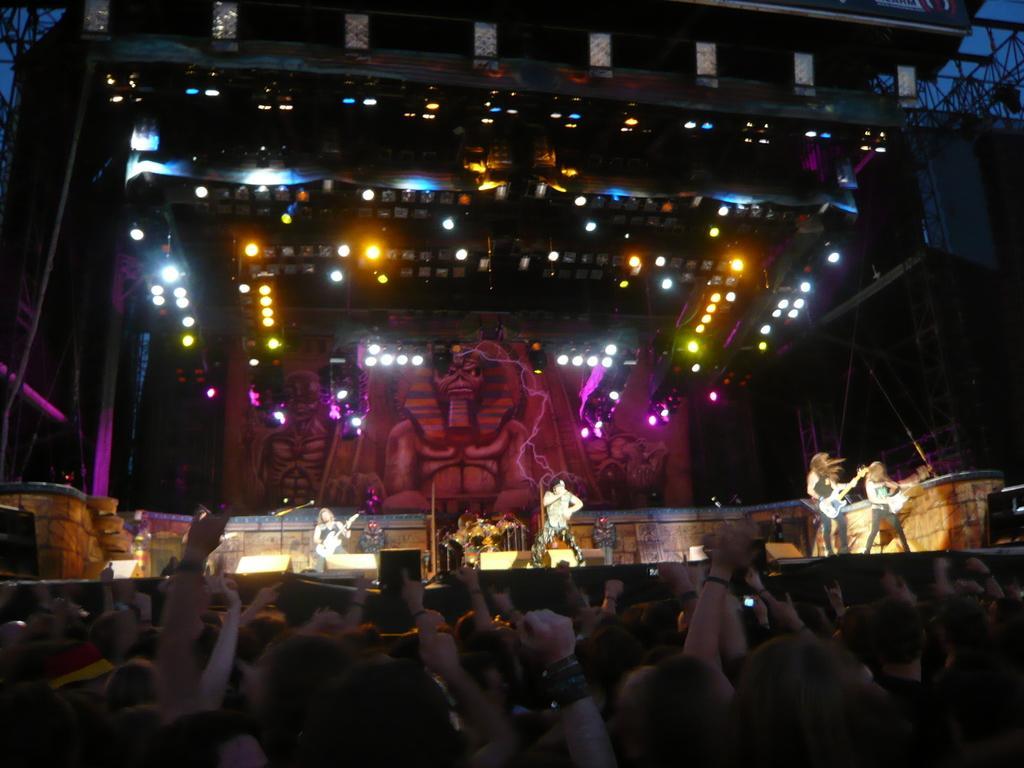Describe this image in one or two sentences. In this image I can see number of persons and in the background I can see the stage and on the stage I can see few persons standing and holding musical instruments, few metal rods, few lights and the dark sky. 